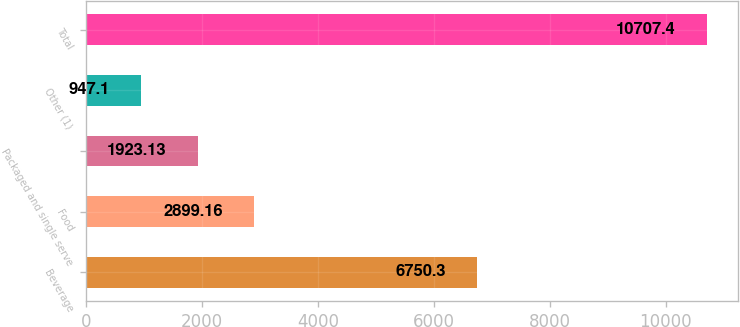<chart> <loc_0><loc_0><loc_500><loc_500><bar_chart><fcel>Beverage<fcel>Food<fcel>Packaged and single serve<fcel>Other (1)<fcel>Total<nl><fcel>6750.3<fcel>2899.16<fcel>1923.13<fcel>947.1<fcel>10707.4<nl></chart> 